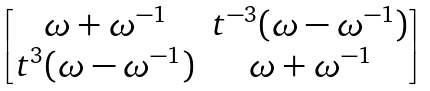<formula> <loc_0><loc_0><loc_500><loc_500>\begin{bmatrix} \omega + \omega ^ { - 1 } & t ^ { - 3 } ( \omega - \omega ^ { - 1 } ) \\ t ^ { 3 } ( \omega - \omega ^ { - 1 } ) & \omega + \omega ^ { - 1 } \end{bmatrix}</formula> 